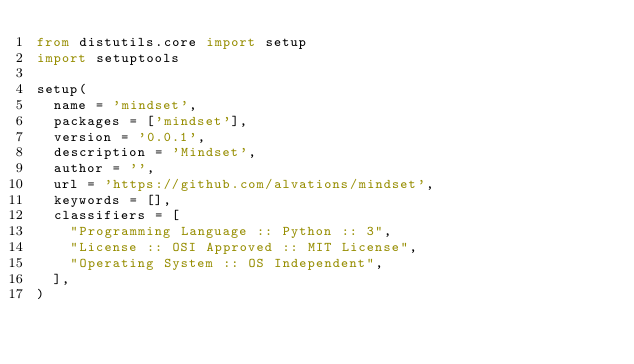<code> <loc_0><loc_0><loc_500><loc_500><_Python_>from distutils.core import setup
import setuptools

setup(
  name = 'mindset',
  packages = ['mindset'],
  version = '0.0.1',
  description = 'Mindset',
  author = '',
  url = 'https://github.com/alvations/mindset',
  keywords = [],
  classifiers = [
    "Programming Language :: Python :: 3",
    "License :: OSI Approved :: MIT License",
    "Operating System :: OS Independent",
  ],
)
</code> 